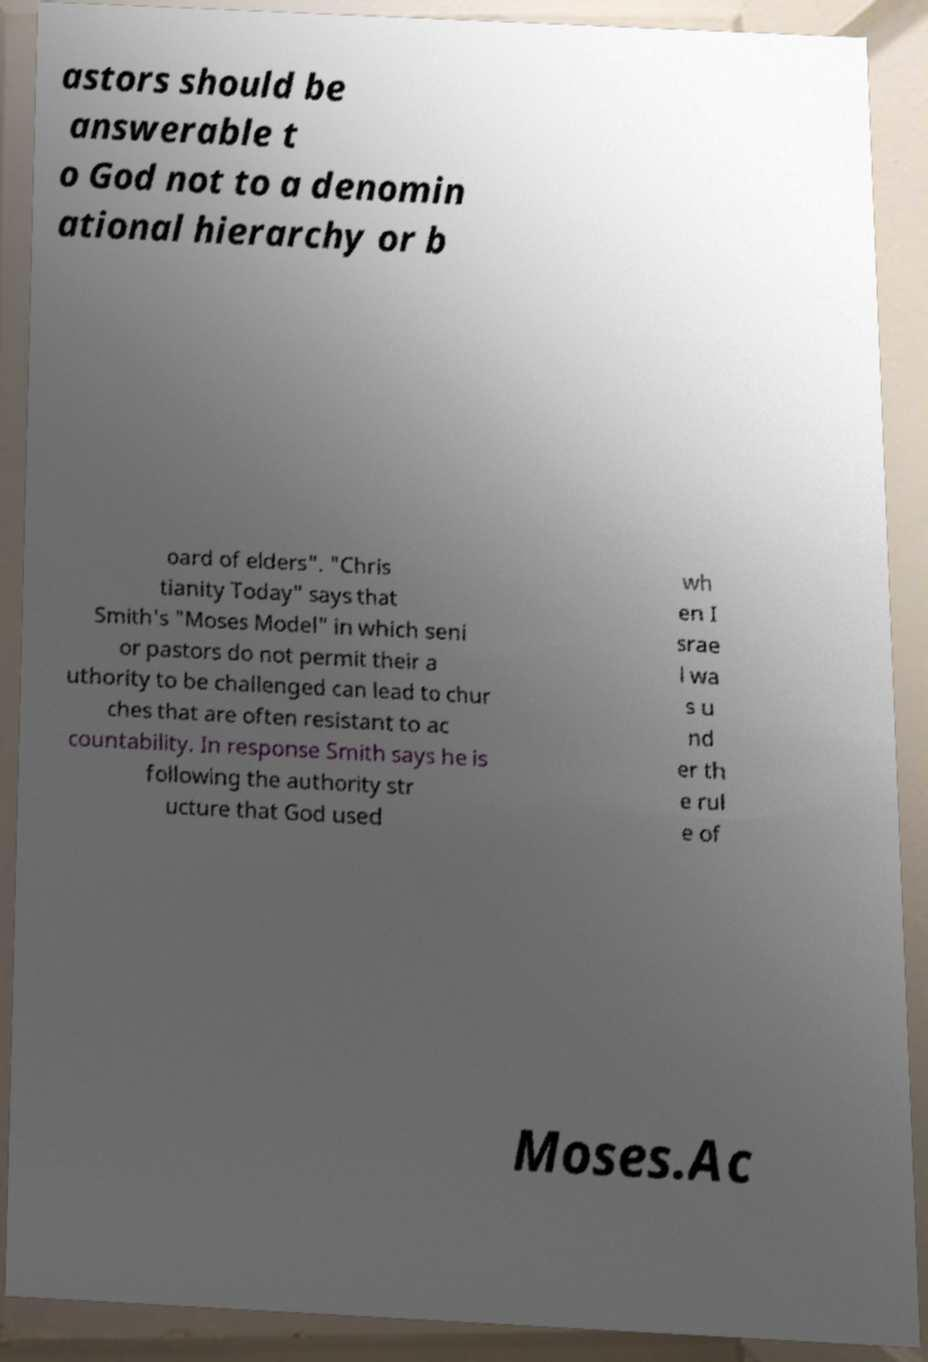For documentation purposes, I need the text within this image transcribed. Could you provide that? astors should be answerable t o God not to a denomin ational hierarchy or b oard of elders". "Chris tianity Today" says that Smith's "Moses Model" in which seni or pastors do not permit their a uthority to be challenged can lead to chur ches that are often resistant to ac countability. In response Smith says he is following the authority str ucture that God used wh en I srae l wa s u nd er th e rul e of Moses.Ac 